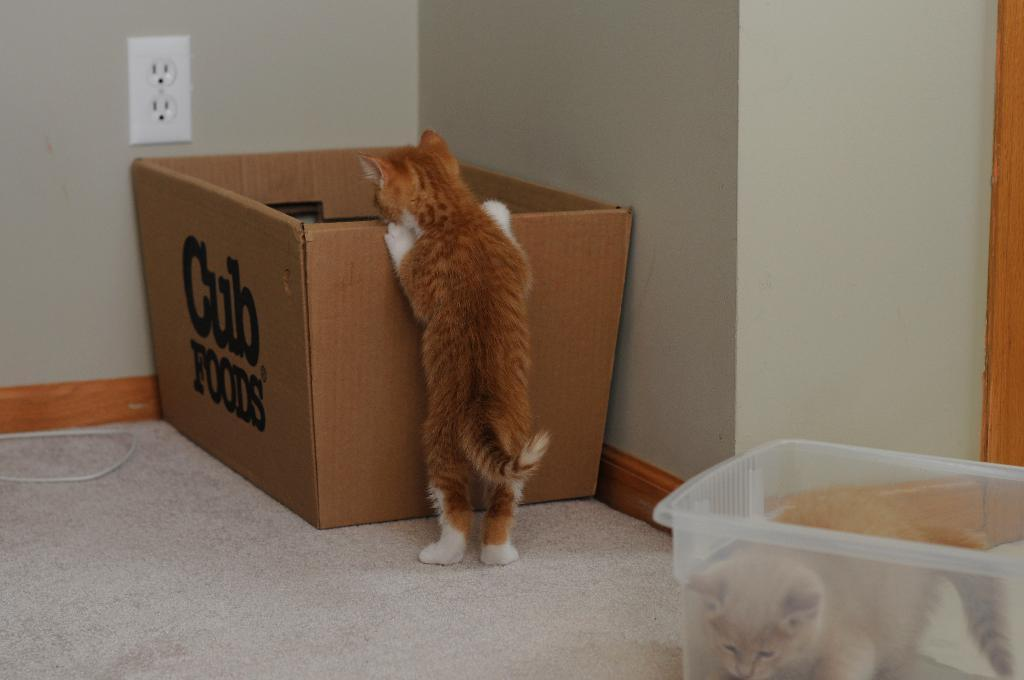<image>
Present a compact description of the photo's key features. Brown cat standing on a cub food box 